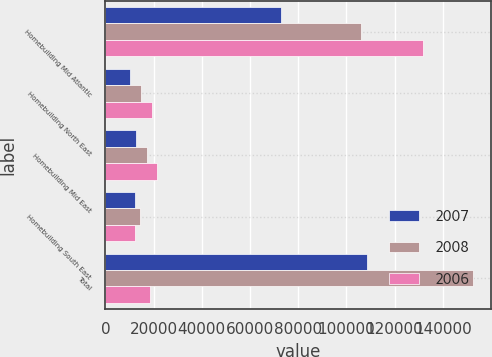<chart> <loc_0><loc_0><loc_500><loc_500><stacked_bar_chart><ecel><fcel>Homebuilding Mid Atlantic<fcel>Homebuilding North East<fcel>Homebuilding Mid East<fcel>Homebuilding South East<fcel>Total<nl><fcel>2007<fcel>73042<fcel>10081<fcel>12902<fcel>12484<fcel>108509<nl><fcel>2008<fcel>106032<fcel>14669<fcel>17381<fcel>14281<fcel>152363<nl><fcel>2006<fcel>131823<fcel>19533<fcel>21235<fcel>12317<fcel>18457<nl></chart> 